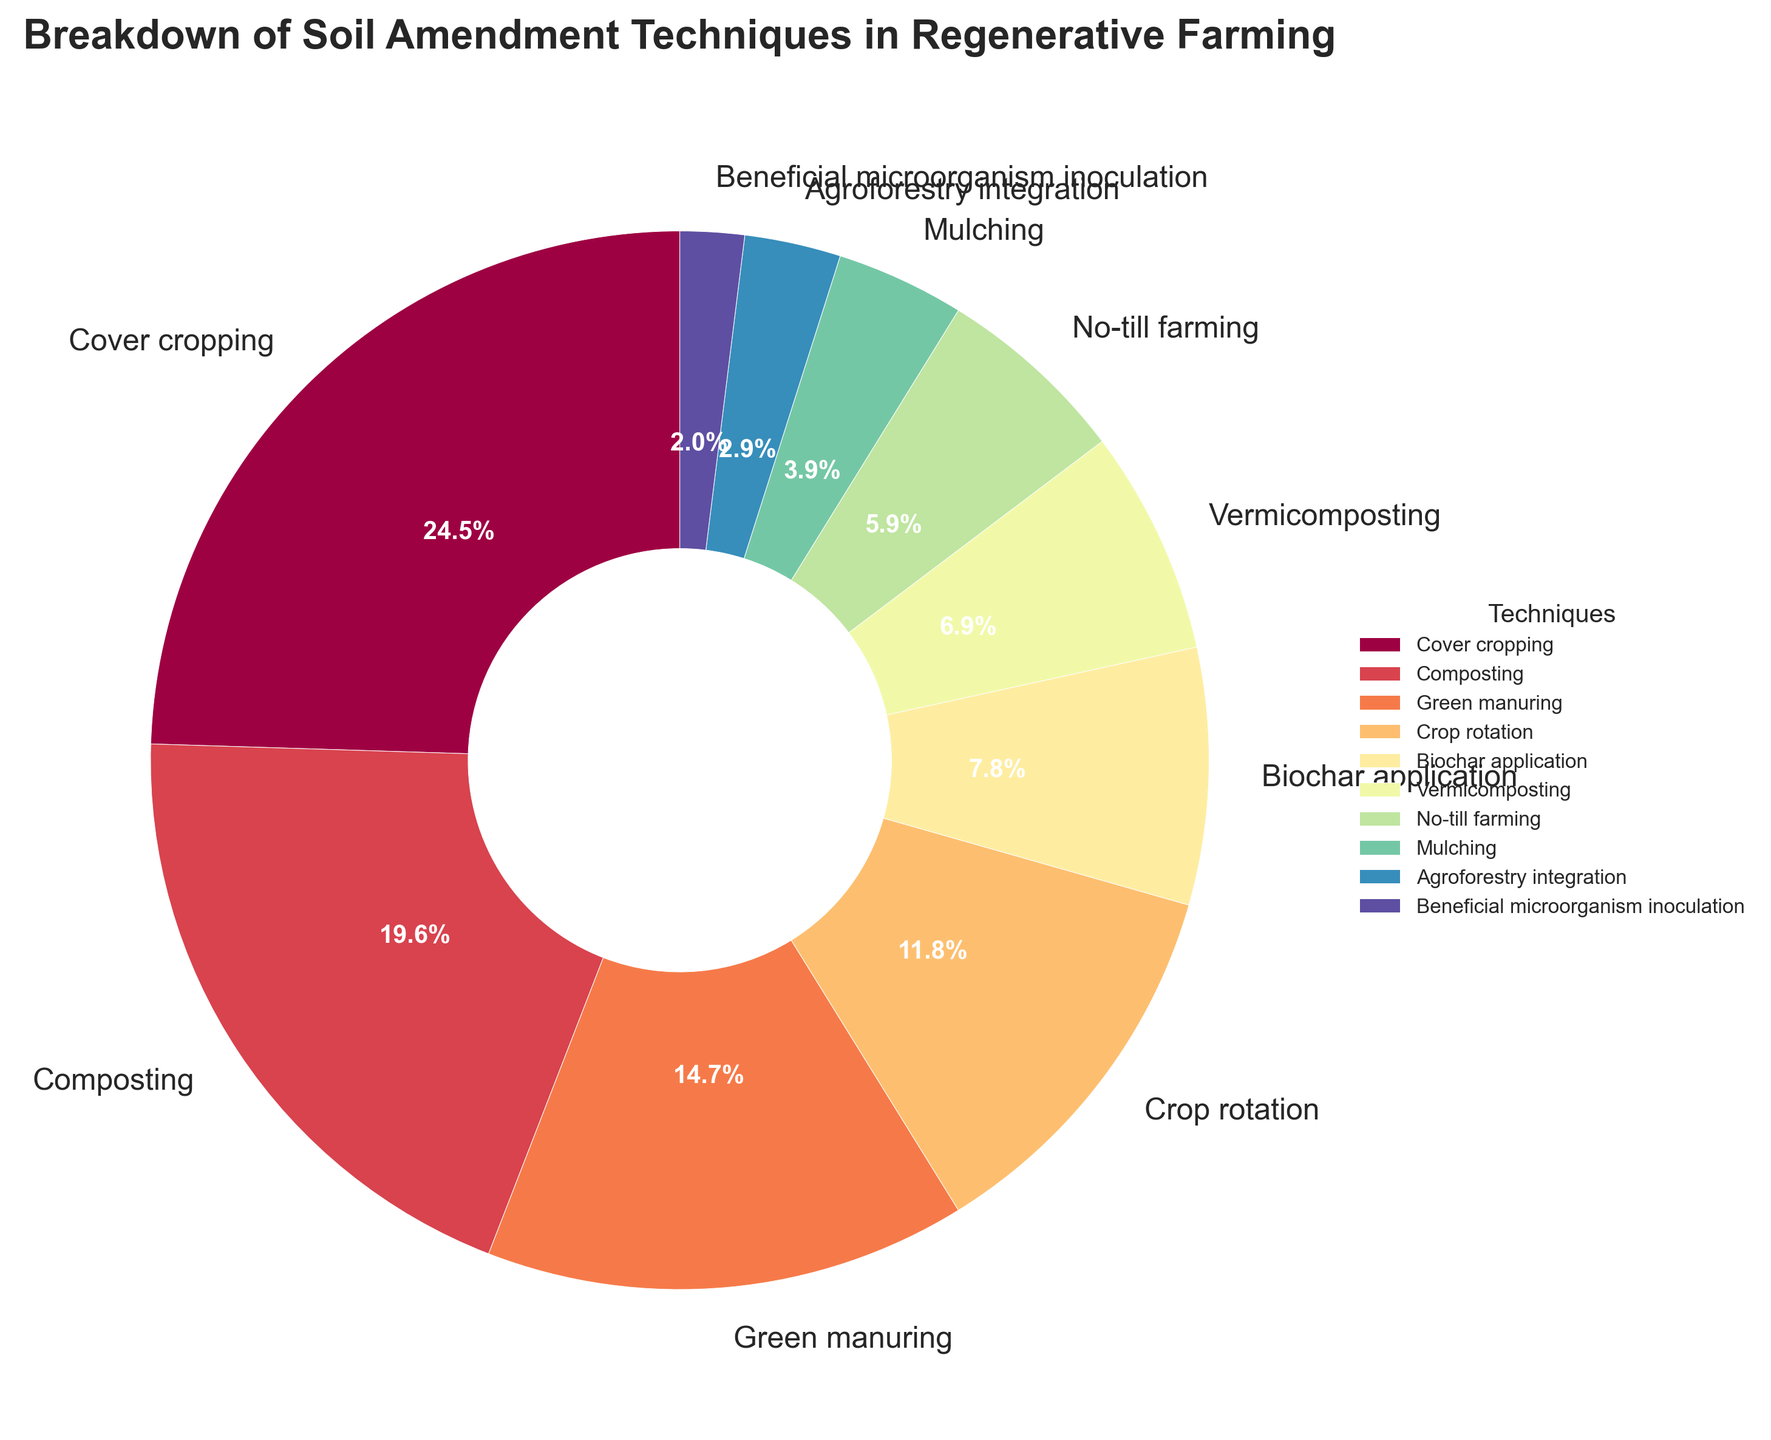What technique represents the largest portion of soil amendment methods in regenerative farming? The figure shows a pie chart with various techniques listed along with their percentages. The segment labeled "Cover cropping" has the largest section.
Answer: Cover cropping Which techniques contribute to more than 20% of the soil amendment methods combined? We need to sum the percentages to find those segments that together exceed 20%. "Cover cropping" alone contributes 25%, which is already more than 20%.
Answer: Cover cropping How do composting and green manuring compare in terms of percentage? Check the percentages for both techniques on the pie chart. Composting is 20% and green manuring is 15%, so composting has a higher percentage.
Answer: Composting is higher What is the combined percentage of no-till farming and agroforestry integration techniques? Sum the percentages of no-till farming (6%) and agroforestry integration (3%) from the chart. 6% + 3% = 9%
Answer: 9% Which two techniques together make up exactly half of the total soil amendment techniques? We add the percentage values of the techniques and check the combinations. "Cover cropping" (25%) and "Composting" (20%) together make 45%, while "Cover cropping" (25%) and "Green manuring" (15%) combined make 40% which matches half of the techniques.
Answer: None Which technique has the lowest percentage in the chart? Observe the segment with the smallest portion; the figure shows that "Beneficial microorganism inoculation" is the smallest at 2%.
Answer: Beneficial microorganism inoculation What is the difference in percentages between crop rotation and biochar application? Subtract the percentage of biochar application (8%) from crop rotation (12%). 12% - 8% = 4%
Answer: 4% How much larger is the cover cropping technique compared to mulching? Subtract the percentage of mulching (4%) from cover cropping (25%). 25% - 4% = 21%
Answer: 21% By how much does the vermicomposting technique exceed the biochar application? Subtract the percentage of biochar application (8%) from vermicomposting (7%). 7% - 8% = -1%. Biochar application actually exceeds vermicomposting by 1%.
Answer: Biochar application exceeds by 1% Which color represents composting on the pie chart? In the pie chart, colors correspond to different techniques. Identify the color associated with "Composting" visually.
Answer: The color of the composting segment 